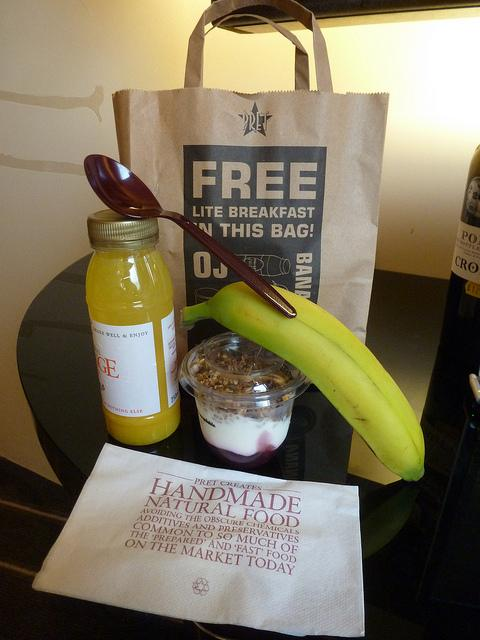What liquid have they been given for breakfast? orange juice 